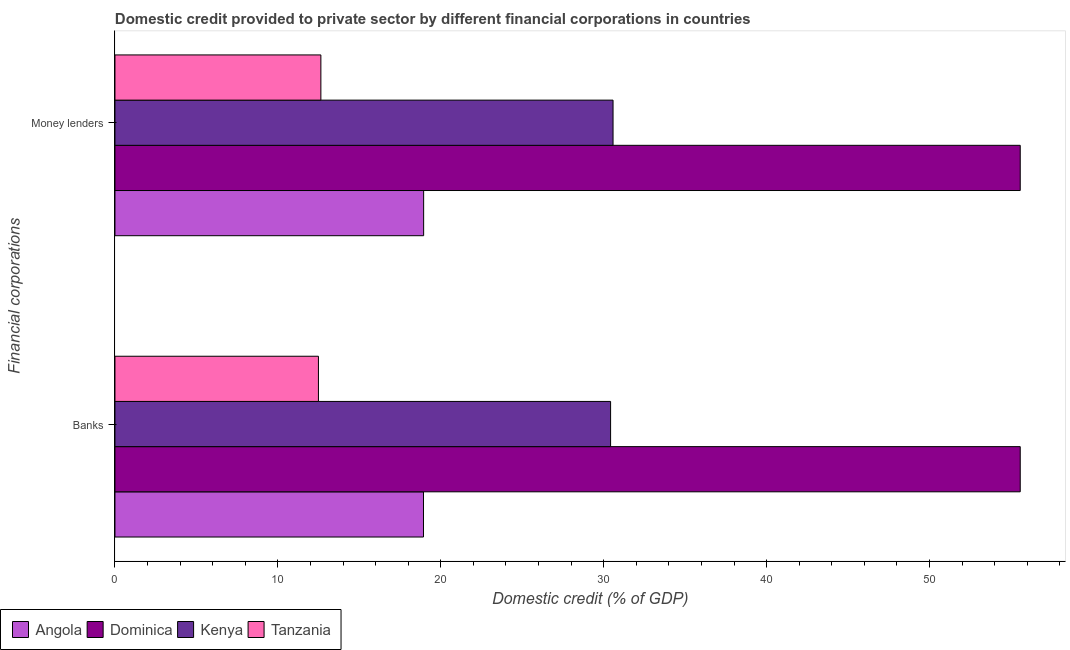How many bars are there on the 1st tick from the top?
Your answer should be very brief. 4. How many bars are there on the 2nd tick from the bottom?
Your response must be concise. 4. What is the label of the 2nd group of bars from the top?
Make the answer very short. Banks. What is the domestic credit provided by banks in Dominica?
Your response must be concise. 55.56. Across all countries, what is the maximum domestic credit provided by money lenders?
Make the answer very short. 55.56. Across all countries, what is the minimum domestic credit provided by banks?
Your response must be concise. 12.49. In which country was the domestic credit provided by money lenders maximum?
Give a very brief answer. Dominica. In which country was the domestic credit provided by money lenders minimum?
Provide a succinct answer. Tanzania. What is the total domestic credit provided by banks in the graph?
Provide a succinct answer. 117.41. What is the difference between the domestic credit provided by banks in Dominica and that in Tanzania?
Offer a very short reply. 43.07. What is the difference between the domestic credit provided by money lenders in Dominica and the domestic credit provided by banks in Tanzania?
Offer a very short reply. 43.07. What is the average domestic credit provided by money lenders per country?
Offer a very short reply. 29.43. In how many countries, is the domestic credit provided by banks greater than 46 %?
Your answer should be very brief. 1. What is the ratio of the domestic credit provided by money lenders in Dominica to that in Tanzania?
Offer a very short reply. 4.4. Is the domestic credit provided by banks in Dominica less than that in Angola?
Provide a short and direct response. No. In how many countries, is the domestic credit provided by money lenders greater than the average domestic credit provided by money lenders taken over all countries?
Make the answer very short. 2. What does the 1st bar from the top in Banks represents?
Make the answer very short. Tanzania. What does the 4th bar from the bottom in Banks represents?
Make the answer very short. Tanzania. Are all the bars in the graph horizontal?
Make the answer very short. Yes. How many countries are there in the graph?
Your answer should be very brief. 4. What is the difference between two consecutive major ticks on the X-axis?
Give a very brief answer. 10. Does the graph contain any zero values?
Ensure brevity in your answer.  No. Where does the legend appear in the graph?
Provide a succinct answer. Bottom left. How many legend labels are there?
Make the answer very short. 4. What is the title of the graph?
Offer a terse response. Domestic credit provided to private sector by different financial corporations in countries. Does "Mali" appear as one of the legend labels in the graph?
Give a very brief answer. No. What is the label or title of the X-axis?
Your answer should be compact. Domestic credit (% of GDP). What is the label or title of the Y-axis?
Offer a very short reply. Financial corporations. What is the Domestic credit (% of GDP) of Angola in Banks?
Ensure brevity in your answer.  18.94. What is the Domestic credit (% of GDP) in Dominica in Banks?
Make the answer very short. 55.56. What is the Domestic credit (% of GDP) in Kenya in Banks?
Ensure brevity in your answer.  30.42. What is the Domestic credit (% of GDP) in Tanzania in Banks?
Your answer should be very brief. 12.49. What is the Domestic credit (% of GDP) of Angola in Money lenders?
Keep it short and to the point. 18.95. What is the Domestic credit (% of GDP) in Dominica in Money lenders?
Offer a terse response. 55.56. What is the Domestic credit (% of GDP) in Kenya in Money lenders?
Provide a short and direct response. 30.57. What is the Domestic credit (% of GDP) in Tanzania in Money lenders?
Offer a very short reply. 12.64. Across all Financial corporations, what is the maximum Domestic credit (% of GDP) of Angola?
Keep it short and to the point. 18.95. Across all Financial corporations, what is the maximum Domestic credit (% of GDP) in Dominica?
Ensure brevity in your answer.  55.56. Across all Financial corporations, what is the maximum Domestic credit (% of GDP) of Kenya?
Offer a terse response. 30.57. Across all Financial corporations, what is the maximum Domestic credit (% of GDP) in Tanzania?
Keep it short and to the point. 12.64. Across all Financial corporations, what is the minimum Domestic credit (% of GDP) in Angola?
Provide a succinct answer. 18.94. Across all Financial corporations, what is the minimum Domestic credit (% of GDP) of Dominica?
Ensure brevity in your answer.  55.56. Across all Financial corporations, what is the minimum Domestic credit (% of GDP) of Kenya?
Ensure brevity in your answer.  30.42. Across all Financial corporations, what is the minimum Domestic credit (% of GDP) of Tanzania?
Your answer should be compact. 12.49. What is the total Domestic credit (% of GDP) in Angola in the graph?
Provide a succinct answer. 37.88. What is the total Domestic credit (% of GDP) in Dominica in the graph?
Your answer should be compact. 111.13. What is the total Domestic credit (% of GDP) in Kenya in the graph?
Provide a short and direct response. 60.99. What is the total Domestic credit (% of GDP) in Tanzania in the graph?
Provide a short and direct response. 25.13. What is the difference between the Domestic credit (% of GDP) in Angola in Banks and that in Money lenders?
Give a very brief answer. -0.01. What is the difference between the Domestic credit (% of GDP) of Dominica in Banks and that in Money lenders?
Ensure brevity in your answer.  0. What is the difference between the Domestic credit (% of GDP) of Kenya in Banks and that in Money lenders?
Your answer should be compact. -0.15. What is the difference between the Domestic credit (% of GDP) of Tanzania in Banks and that in Money lenders?
Your response must be concise. -0.15. What is the difference between the Domestic credit (% of GDP) in Angola in Banks and the Domestic credit (% of GDP) in Dominica in Money lenders?
Your answer should be compact. -36.63. What is the difference between the Domestic credit (% of GDP) of Angola in Banks and the Domestic credit (% of GDP) of Kenya in Money lenders?
Offer a terse response. -11.64. What is the difference between the Domestic credit (% of GDP) in Angola in Banks and the Domestic credit (% of GDP) in Tanzania in Money lenders?
Offer a terse response. 6.3. What is the difference between the Domestic credit (% of GDP) in Dominica in Banks and the Domestic credit (% of GDP) in Kenya in Money lenders?
Offer a terse response. 24.99. What is the difference between the Domestic credit (% of GDP) of Dominica in Banks and the Domestic credit (% of GDP) of Tanzania in Money lenders?
Give a very brief answer. 42.93. What is the difference between the Domestic credit (% of GDP) of Kenya in Banks and the Domestic credit (% of GDP) of Tanzania in Money lenders?
Your answer should be very brief. 17.78. What is the average Domestic credit (% of GDP) of Angola per Financial corporations?
Ensure brevity in your answer.  18.94. What is the average Domestic credit (% of GDP) in Dominica per Financial corporations?
Keep it short and to the point. 55.56. What is the average Domestic credit (% of GDP) of Kenya per Financial corporations?
Give a very brief answer. 30.5. What is the average Domestic credit (% of GDP) of Tanzania per Financial corporations?
Provide a succinct answer. 12.56. What is the difference between the Domestic credit (% of GDP) of Angola and Domestic credit (% of GDP) of Dominica in Banks?
Your answer should be very brief. -36.63. What is the difference between the Domestic credit (% of GDP) in Angola and Domestic credit (% of GDP) in Kenya in Banks?
Give a very brief answer. -11.48. What is the difference between the Domestic credit (% of GDP) in Angola and Domestic credit (% of GDP) in Tanzania in Banks?
Offer a very short reply. 6.45. What is the difference between the Domestic credit (% of GDP) in Dominica and Domestic credit (% of GDP) in Kenya in Banks?
Provide a succinct answer. 25.14. What is the difference between the Domestic credit (% of GDP) of Dominica and Domestic credit (% of GDP) of Tanzania in Banks?
Your response must be concise. 43.07. What is the difference between the Domestic credit (% of GDP) of Kenya and Domestic credit (% of GDP) of Tanzania in Banks?
Offer a very short reply. 17.93. What is the difference between the Domestic credit (% of GDP) of Angola and Domestic credit (% of GDP) of Dominica in Money lenders?
Offer a very short reply. -36.62. What is the difference between the Domestic credit (% of GDP) of Angola and Domestic credit (% of GDP) of Kenya in Money lenders?
Make the answer very short. -11.63. What is the difference between the Domestic credit (% of GDP) of Angola and Domestic credit (% of GDP) of Tanzania in Money lenders?
Give a very brief answer. 6.31. What is the difference between the Domestic credit (% of GDP) in Dominica and Domestic credit (% of GDP) in Kenya in Money lenders?
Your answer should be compact. 24.99. What is the difference between the Domestic credit (% of GDP) in Dominica and Domestic credit (% of GDP) in Tanzania in Money lenders?
Ensure brevity in your answer.  42.93. What is the difference between the Domestic credit (% of GDP) in Kenya and Domestic credit (% of GDP) in Tanzania in Money lenders?
Offer a very short reply. 17.93. What is the difference between the highest and the second highest Domestic credit (% of GDP) in Angola?
Offer a very short reply. 0.01. What is the difference between the highest and the second highest Domestic credit (% of GDP) of Kenya?
Provide a short and direct response. 0.15. What is the difference between the highest and the second highest Domestic credit (% of GDP) in Tanzania?
Give a very brief answer. 0.15. What is the difference between the highest and the lowest Domestic credit (% of GDP) of Angola?
Your answer should be very brief. 0.01. What is the difference between the highest and the lowest Domestic credit (% of GDP) of Kenya?
Provide a short and direct response. 0.15. What is the difference between the highest and the lowest Domestic credit (% of GDP) in Tanzania?
Give a very brief answer. 0.15. 